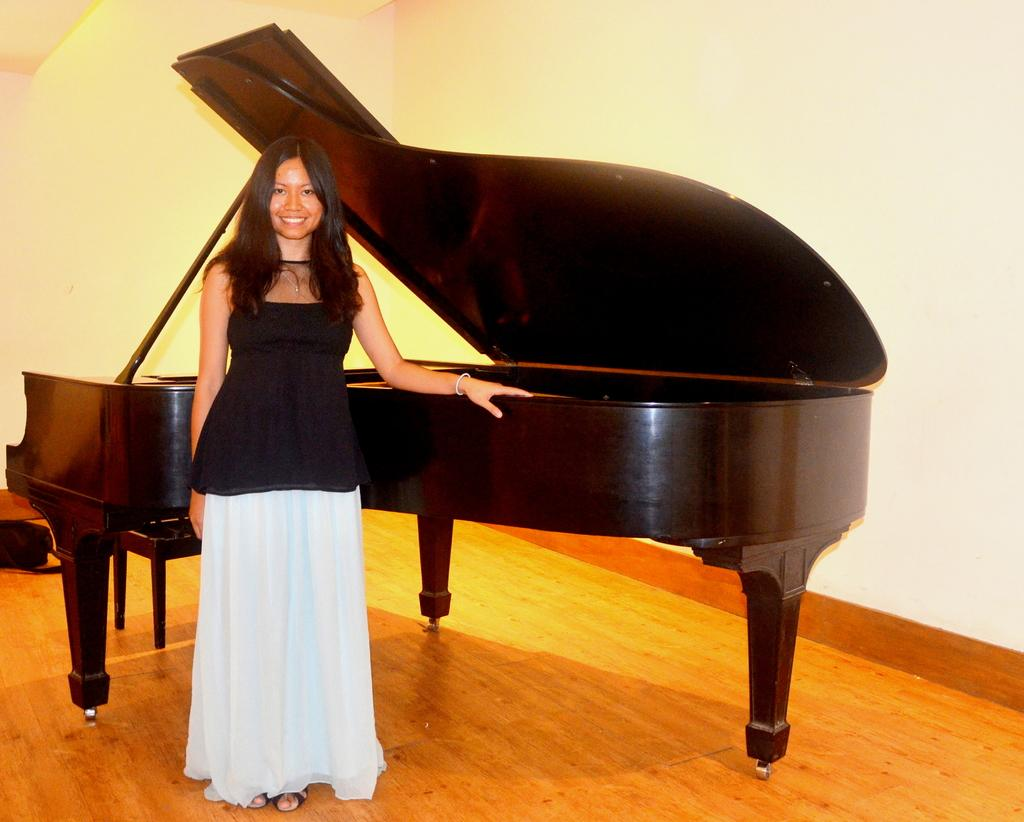Who is the main subject in the picture? There is a girl in the picture. What is the girl standing in front of? The girl is standing in front of a piano. What is the girl doing with her hand? The girl is placing her hand on the piano. What can be seen in the background of the picture? There is a wall in the background of the picture. What is the girl's facial expression? The girl is smiling. What type of memory is the girl trying to recall while playing the piano in the image? There is no indication in the image that the girl is trying to recall a memory or playing the piano; she is simply placing her hand on it. 